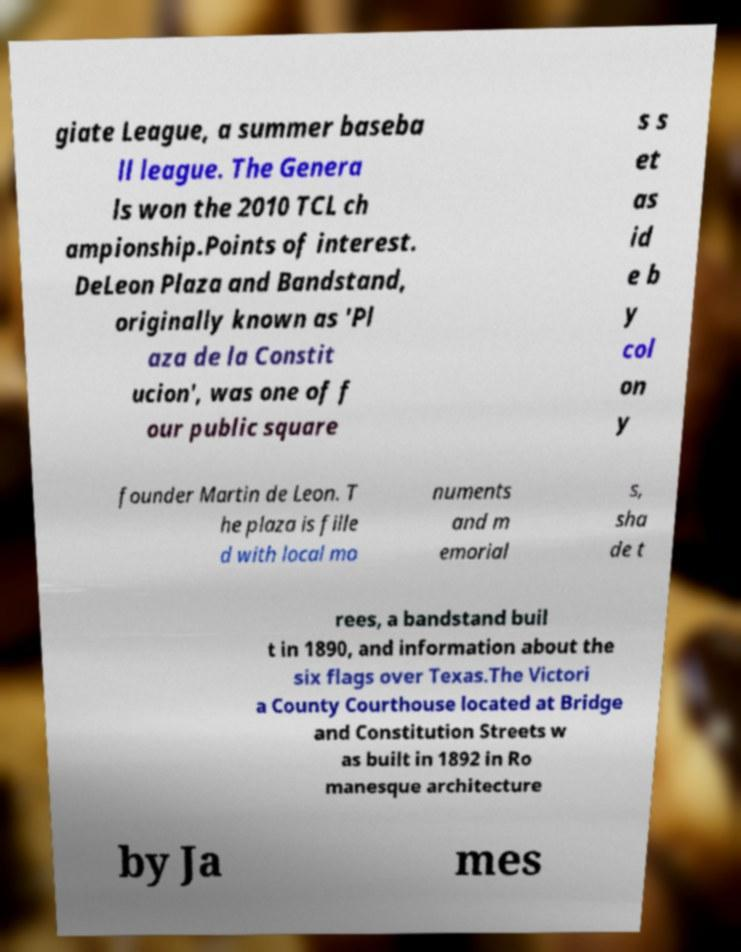Could you assist in decoding the text presented in this image and type it out clearly? giate League, a summer baseba ll league. The Genera ls won the 2010 TCL ch ampionship.Points of interest. DeLeon Plaza and Bandstand, originally known as 'Pl aza de la Constit ucion', was one of f our public square s s et as id e b y col on y founder Martin de Leon. T he plaza is fille d with local mo numents and m emorial s, sha de t rees, a bandstand buil t in 1890, and information about the six flags over Texas.The Victori a County Courthouse located at Bridge and Constitution Streets w as built in 1892 in Ro manesque architecture by Ja mes 